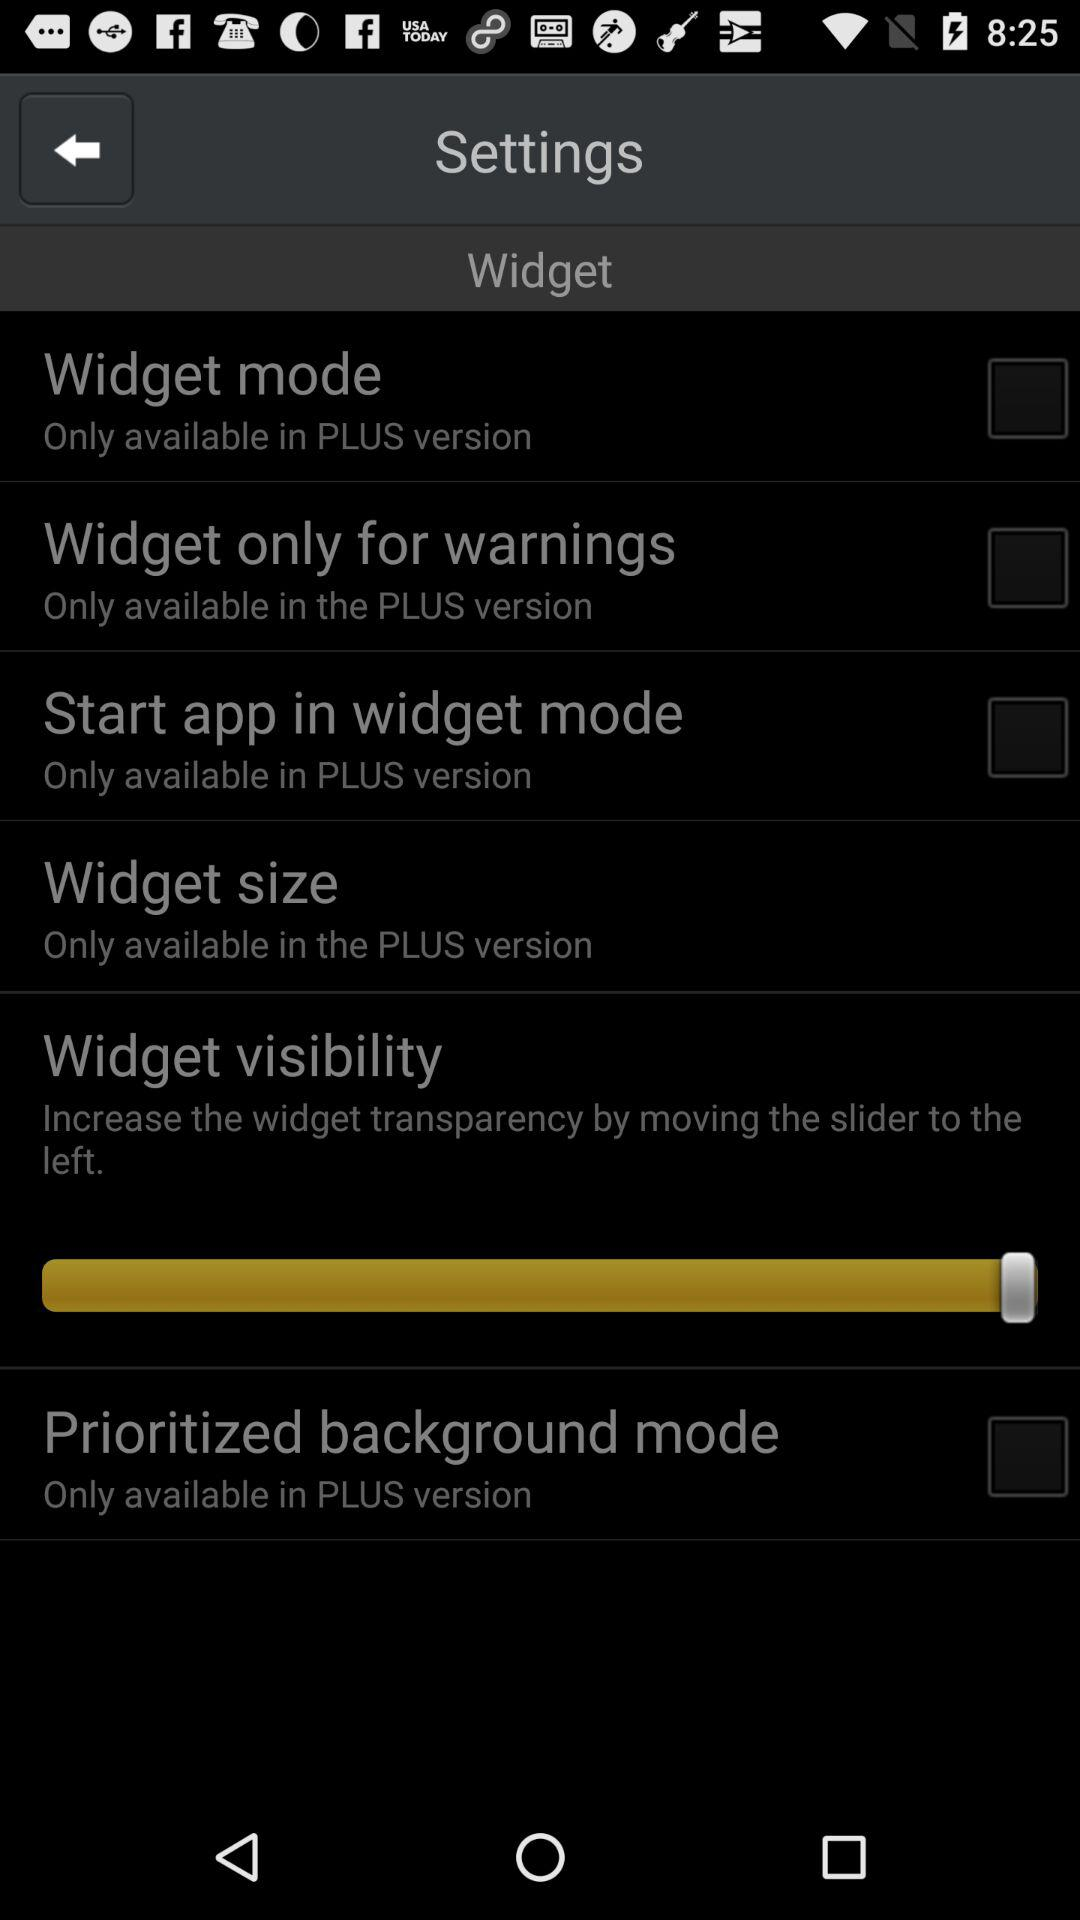How many items are in the widget settings screen that are only available in the PLUS version?
Answer the question using a single word or phrase. 5 